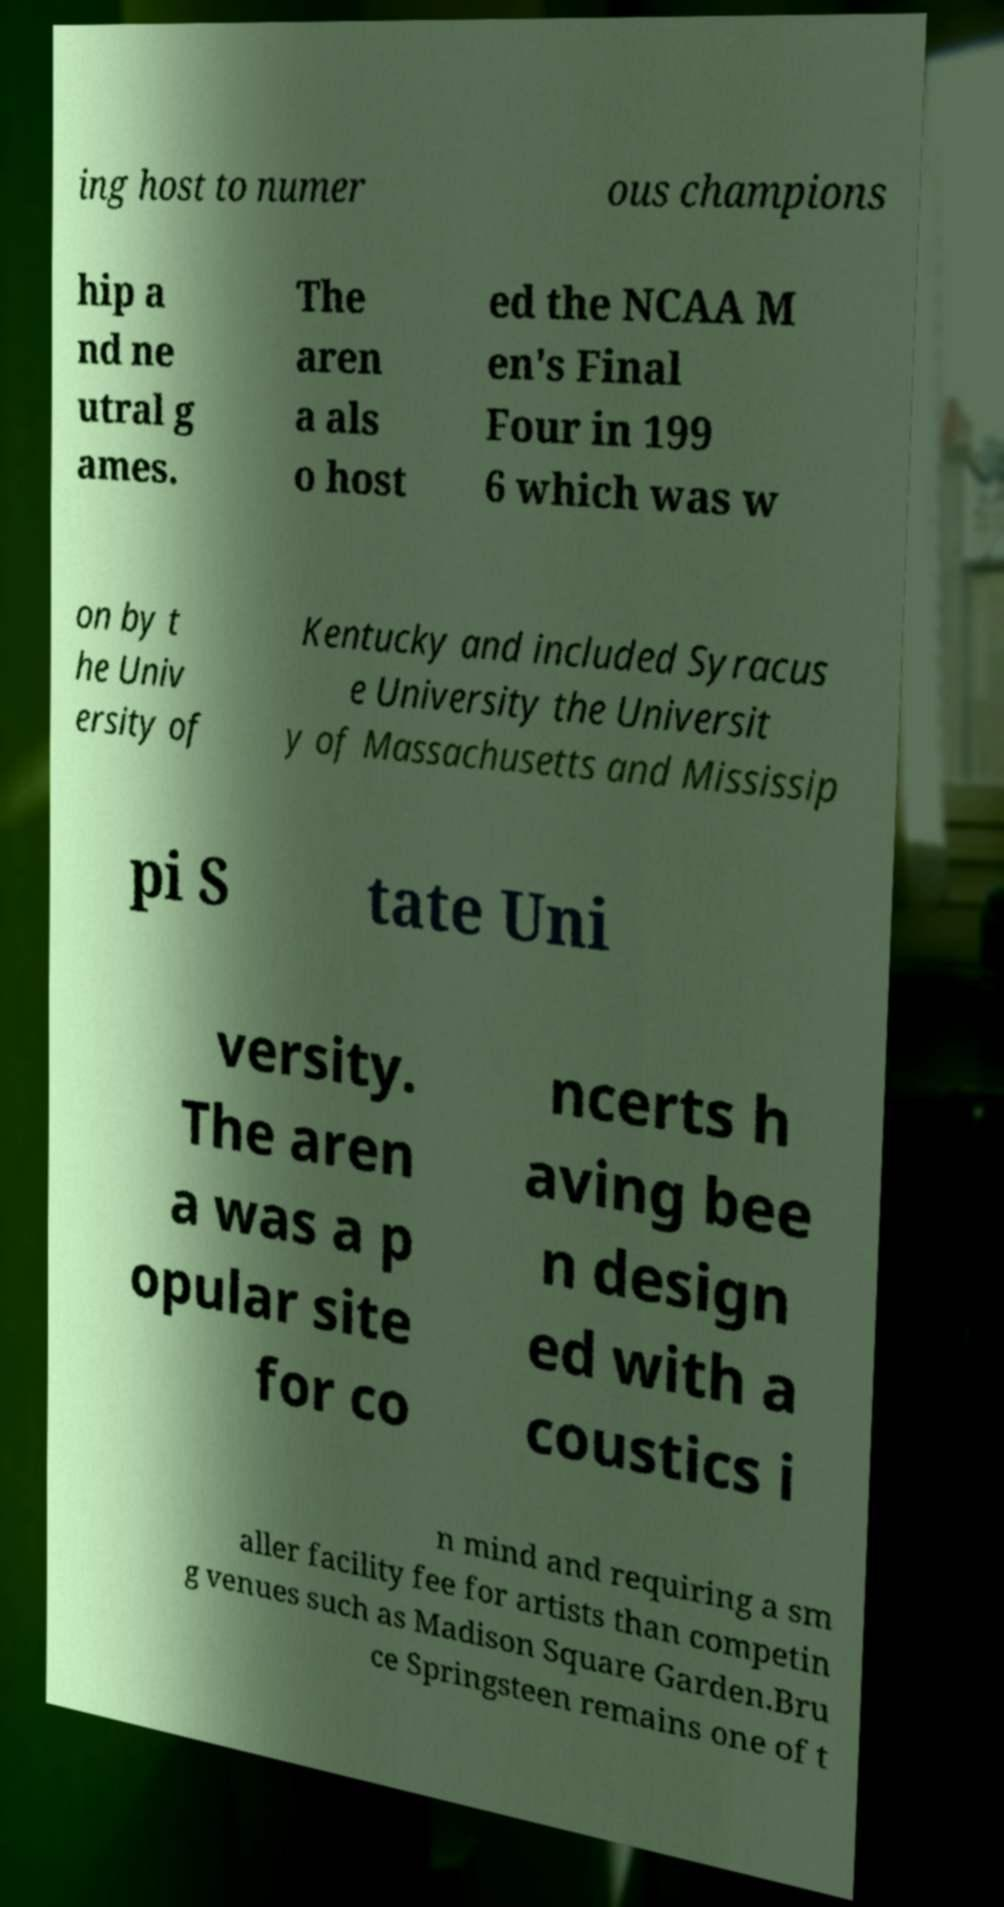I need the written content from this picture converted into text. Can you do that? ing host to numer ous champions hip a nd ne utral g ames. The aren a als o host ed the NCAA M en's Final Four in 199 6 which was w on by t he Univ ersity of Kentucky and included Syracus e University the Universit y of Massachusetts and Mississip pi S tate Uni versity. The aren a was a p opular site for co ncerts h aving bee n design ed with a coustics i n mind and requiring a sm aller facility fee for artists than competin g venues such as Madison Square Garden.Bru ce Springsteen remains one of t 